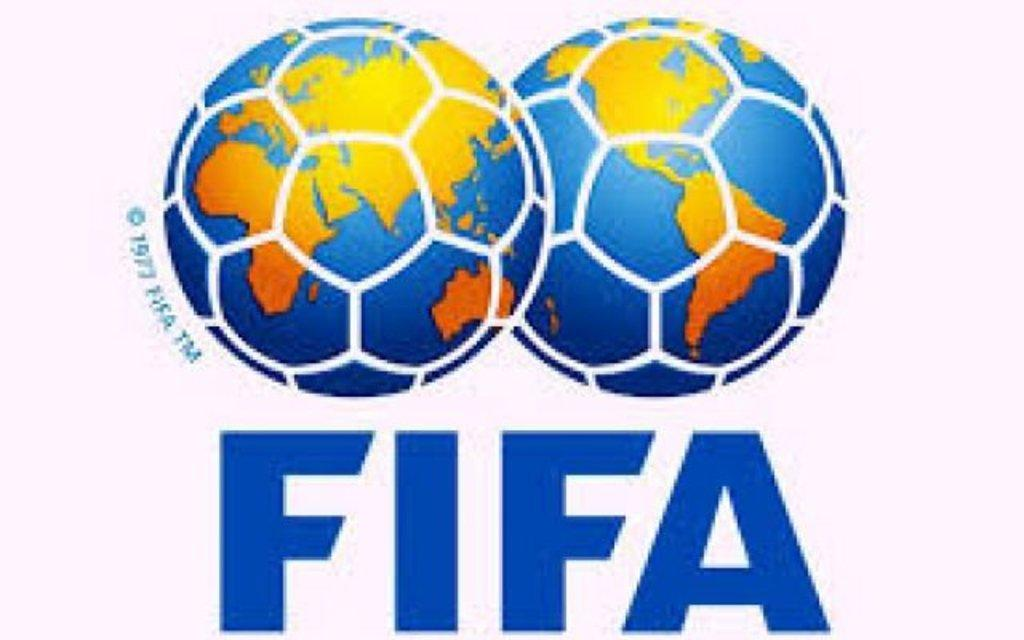What type of art is featured in the image? The image contains digital art. How many globes are depicted in the image? There are two globes depicted in the image. What colors are the globes? The globes are blue, orange, and gold in color. What shape are the globes? The globes are in the shape of a soccer ball. What is the background color of the image? The background of the image is white. Can you tell me what the sisters are reading in the image? There are no sisters or any reading material present in the image; it features digital art with two globes. 